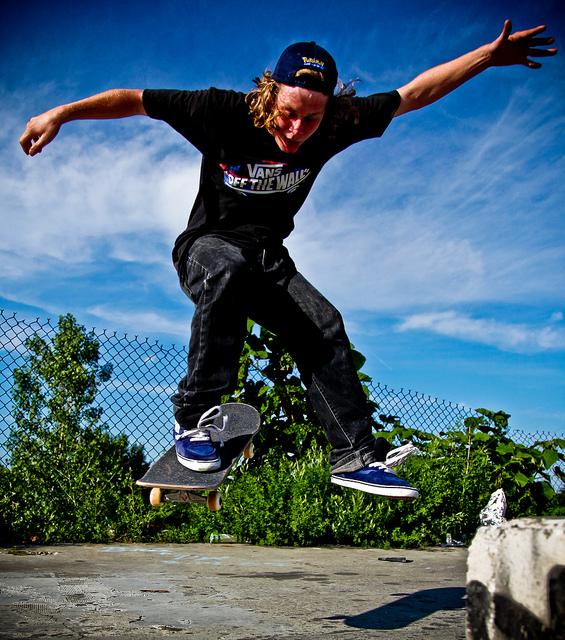Is the male jumping from a wooden bench?
Write a very short answer. No. What does his skateboard say?
Concise answer only. Nothing. What is the person doing?
Give a very brief answer. Skateboarding. What color are the skaters shoes?
Concise answer only. Blue. Is the fence chicken wire or chain-link?
Short answer required. Chain link. On which wrist is the man wearing something?
Write a very short answer. Neither. What brand shoes are the person wearing?
Give a very brief answer. Nike. What color are his wheels?
Give a very brief answer. Orange. 